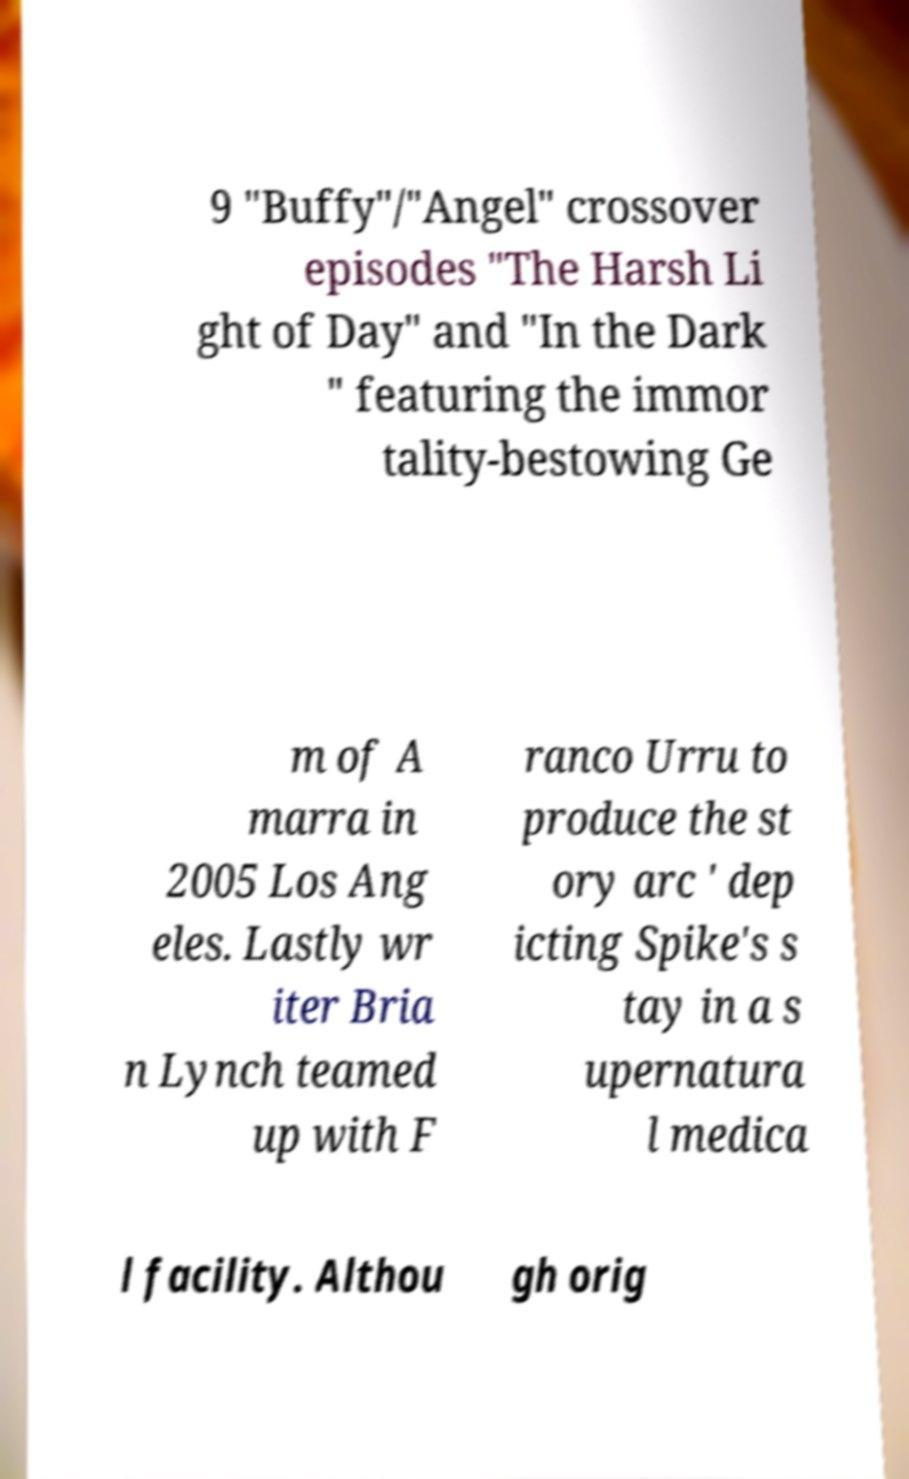Please identify and transcribe the text found in this image. 9 "Buffy"/"Angel" crossover episodes "The Harsh Li ght of Day" and "In the Dark " featuring the immor tality-bestowing Ge m of A marra in 2005 Los Ang eles. Lastly wr iter Bria n Lynch teamed up with F ranco Urru to produce the st ory arc ' dep icting Spike's s tay in a s upernatura l medica l facility. Althou gh orig 